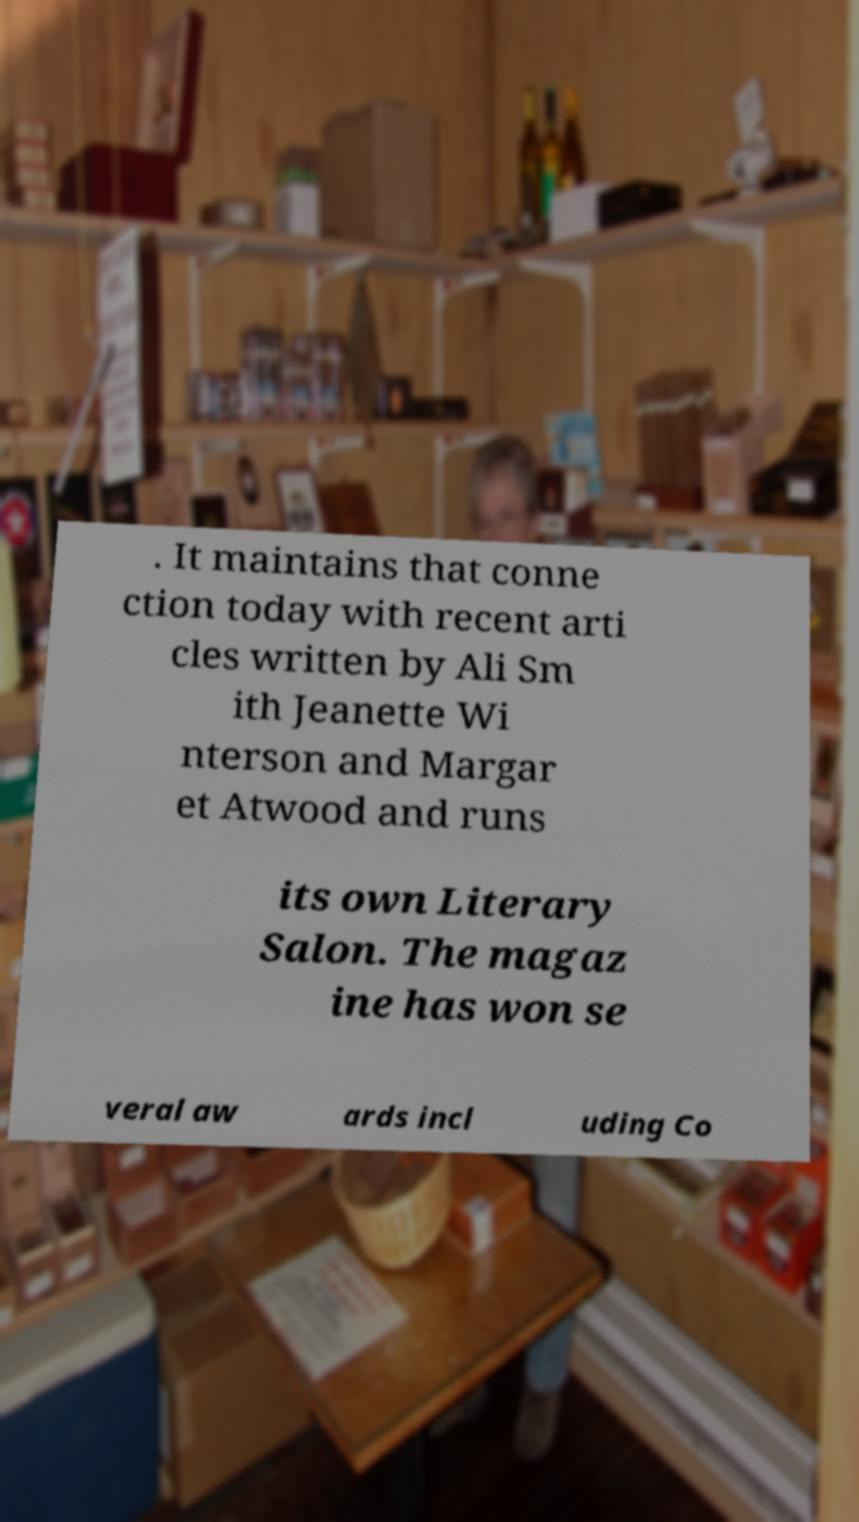For documentation purposes, I need the text within this image transcribed. Could you provide that? . It maintains that conne ction today with recent arti cles written by Ali Sm ith Jeanette Wi nterson and Margar et Atwood and runs its own Literary Salon. The magaz ine has won se veral aw ards incl uding Co 